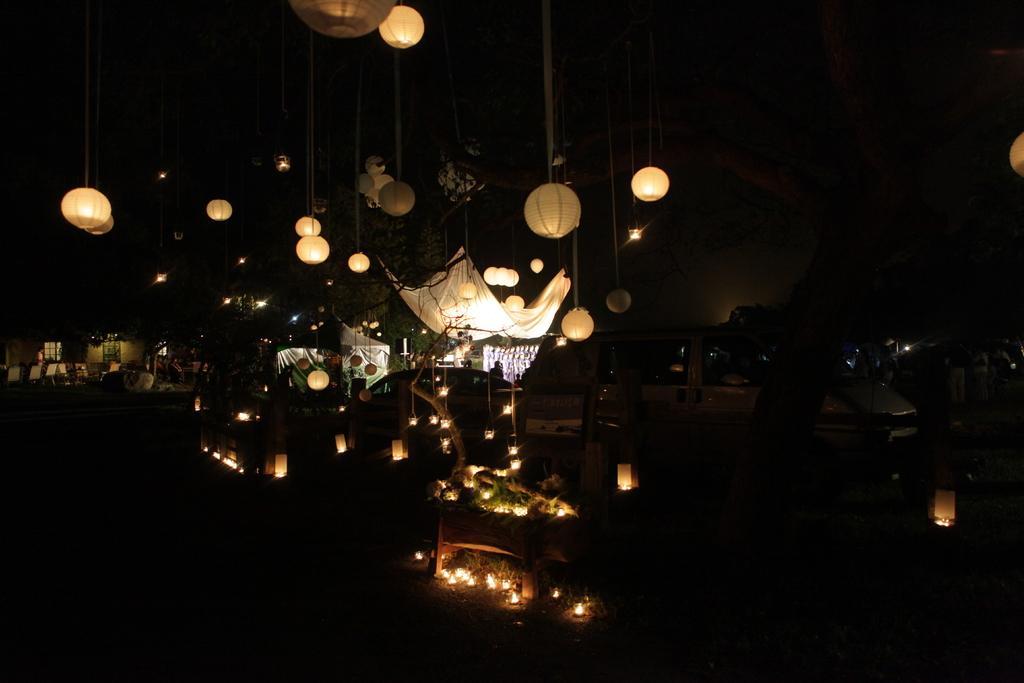How would you summarize this image in a sentence or two? In this picture we can see the lanterns, cloth, tent, car, a person is standing, building, chairs, window. In the background, the image is dark. 